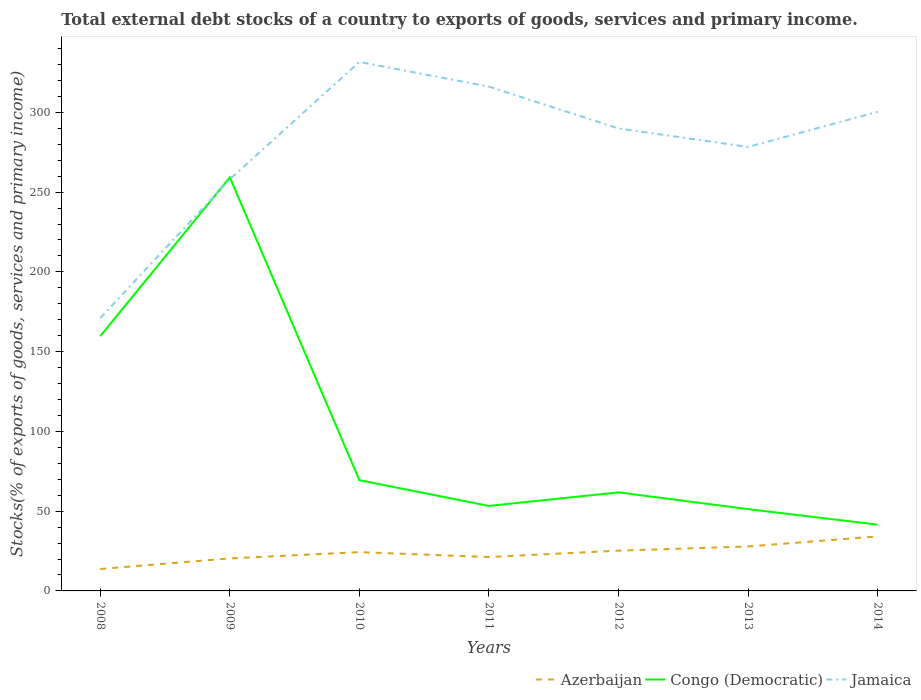Does the line corresponding to Jamaica intersect with the line corresponding to Azerbaijan?
Make the answer very short. No. Across all years, what is the maximum total debt stocks in Azerbaijan?
Provide a short and direct response. 13.75. In which year was the total debt stocks in Congo (Democratic) maximum?
Your answer should be compact. 2014. What is the total total debt stocks in Jamaica in the graph?
Your response must be concise. -10.41. What is the difference between the highest and the second highest total debt stocks in Jamaica?
Provide a succinct answer. 160.57. Is the total debt stocks in Jamaica strictly greater than the total debt stocks in Azerbaijan over the years?
Your answer should be compact. No. How many lines are there?
Make the answer very short. 3. How many years are there in the graph?
Offer a terse response. 7. Does the graph contain any zero values?
Your response must be concise. No. Where does the legend appear in the graph?
Offer a very short reply. Bottom right. What is the title of the graph?
Make the answer very short. Total external debt stocks of a country to exports of goods, services and primary income. Does "Germany" appear as one of the legend labels in the graph?
Ensure brevity in your answer.  No. What is the label or title of the Y-axis?
Offer a terse response. Stocks(% of exports of goods, services and primary income). What is the Stocks(% of exports of goods, services and primary income) in Azerbaijan in 2008?
Make the answer very short. 13.75. What is the Stocks(% of exports of goods, services and primary income) in Congo (Democratic) in 2008?
Your response must be concise. 159.7. What is the Stocks(% of exports of goods, services and primary income) of Jamaica in 2008?
Your answer should be very brief. 171.03. What is the Stocks(% of exports of goods, services and primary income) in Azerbaijan in 2009?
Give a very brief answer. 20.4. What is the Stocks(% of exports of goods, services and primary income) in Congo (Democratic) in 2009?
Your answer should be very brief. 259.23. What is the Stocks(% of exports of goods, services and primary income) of Jamaica in 2009?
Your answer should be compact. 258.03. What is the Stocks(% of exports of goods, services and primary income) in Azerbaijan in 2010?
Offer a very short reply. 24.31. What is the Stocks(% of exports of goods, services and primary income) of Congo (Democratic) in 2010?
Your response must be concise. 69.42. What is the Stocks(% of exports of goods, services and primary income) of Jamaica in 2010?
Keep it short and to the point. 331.59. What is the Stocks(% of exports of goods, services and primary income) of Azerbaijan in 2011?
Provide a short and direct response. 21.24. What is the Stocks(% of exports of goods, services and primary income) in Congo (Democratic) in 2011?
Ensure brevity in your answer.  53.28. What is the Stocks(% of exports of goods, services and primary income) of Jamaica in 2011?
Provide a succinct answer. 316.11. What is the Stocks(% of exports of goods, services and primary income) in Azerbaijan in 2012?
Offer a very short reply. 25.24. What is the Stocks(% of exports of goods, services and primary income) of Congo (Democratic) in 2012?
Make the answer very short. 61.78. What is the Stocks(% of exports of goods, services and primary income) in Jamaica in 2012?
Offer a terse response. 289.91. What is the Stocks(% of exports of goods, services and primary income) of Azerbaijan in 2013?
Provide a short and direct response. 27.87. What is the Stocks(% of exports of goods, services and primary income) in Congo (Democratic) in 2013?
Make the answer very short. 51.27. What is the Stocks(% of exports of goods, services and primary income) of Jamaica in 2013?
Your answer should be very brief. 278.31. What is the Stocks(% of exports of goods, services and primary income) in Azerbaijan in 2014?
Provide a succinct answer. 34.16. What is the Stocks(% of exports of goods, services and primary income) in Congo (Democratic) in 2014?
Keep it short and to the point. 41.55. What is the Stocks(% of exports of goods, services and primary income) of Jamaica in 2014?
Your answer should be compact. 300.32. Across all years, what is the maximum Stocks(% of exports of goods, services and primary income) of Azerbaijan?
Offer a terse response. 34.16. Across all years, what is the maximum Stocks(% of exports of goods, services and primary income) of Congo (Democratic)?
Give a very brief answer. 259.23. Across all years, what is the maximum Stocks(% of exports of goods, services and primary income) in Jamaica?
Give a very brief answer. 331.59. Across all years, what is the minimum Stocks(% of exports of goods, services and primary income) of Azerbaijan?
Offer a very short reply. 13.75. Across all years, what is the minimum Stocks(% of exports of goods, services and primary income) in Congo (Democratic)?
Your answer should be very brief. 41.55. Across all years, what is the minimum Stocks(% of exports of goods, services and primary income) of Jamaica?
Provide a short and direct response. 171.03. What is the total Stocks(% of exports of goods, services and primary income) in Azerbaijan in the graph?
Ensure brevity in your answer.  166.97. What is the total Stocks(% of exports of goods, services and primary income) of Congo (Democratic) in the graph?
Your answer should be compact. 696.24. What is the total Stocks(% of exports of goods, services and primary income) in Jamaica in the graph?
Offer a terse response. 1945.3. What is the difference between the Stocks(% of exports of goods, services and primary income) in Azerbaijan in 2008 and that in 2009?
Offer a terse response. -6.65. What is the difference between the Stocks(% of exports of goods, services and primary income) in Congo (Democratic) in 2008 and that in 2009?
Your answer should be very brief. -99.53. What is the difference between the Stocks(% of exports of goods, services and primary income) of Jamaica in 2008 and that in 2009?
Offer a very short reply. -87. What is the difference between the Stocks(% of exports of goods, services and primary income) in Azerbaijan in 2008 and that in 2010?
Keep it short and to the point. -10.57. What is the difference between the Stocks(% of exports of goods, services and primary income) of Congo (Democratic) in 2008 and that in 2010?
Your response must be concise. 90.29. What is the difference between the Stocks(% of exports of goods, services and primary income) in Jamaica in 2008 and that in 2010?
Give a very brief answer. -160.57. What is the difference between the Stocks(% of exports of goods, services and primary income) in Azerbaijan in 2008 and that in 2011?
Provide a short and direct response. -7.5. What is the difference between the Stocks(% of exports of goods, services and primary income) of Congo (Democratic) in 2008 and that in 2011?
Your answer should be compact. 106.42. What is the difference between the Stocks(% of exports of goods, services and primary income) of Jamaica in 2008 and that in 2011?
Make the answer very short. -145.09. What is the difference between the Stocks(% of exports of goods, services and primary income) in Azerbaijan in 2008 and that in 2012?
Provide a short and direct response. -11.5. What is the difference between the Stocks(% of exports of goods, services and primary income) in Congo (Democratic) in 2008 and that in 2012?
Your answer should be compact. 97.92. What is the difference between the Stocks(% of exports of goods, services and primary income) in Jamaica in 2008 and that in 2012?
Give a very brief answer. -118.88. What is the difference between the Stocks(% of exports of goods, services and primary income) in Azerbaijan in 2008 and that in 2013?
Make the answer very short. -14.12. What is the difference between the Stocks(% of exports of goods, services and primary income) in Congo (Democratic) in 2008 and that in 2013?
Your answer should be compact. 108.43. What is the difference between the Stocks(% of exports of goods, services and primary income) of Jamaica in 2008 and that in 2013?
Provide a succinct answer. -107.29. What is the difference between the Stocks(% of exports of goods, services and primary income) in Azerbaijan in 2008 and that in 2014?
Offer a very short reply. -20.41. What is the difference between the Stocks(% of exports of goods, services and primary income) of Congo (Democratic) in 2008 and that in 2014?
Your answer should be very brief. 118.15. What is the difference between the Stocks(% of exports of goods, services and primary income) in Jamaica in 2008 and that in 2014?
Offer a terse response. -129.3. What is the difference between the Stocks(% of exports of goods, services and primary income) in Azerbaijan in 2009 and that in 2010?
Your answer should be very brief. -3.92. What is the difference between the Stocks(% of exports of goods, services and primary income) in Congo (Democratic) in 2009 and that in 2010?
Provide a succinct answer. 189.82. What is the difference between the Stocks(% of exports of goods, services and primary income) of Jamaica in 2009 and that in 2010?
Your answer should be compact. -73.57. What is the difference between the Stocks(% of exports of goods, services and primary income) in Azerbaijan in 2009 and that in 2011?
Provide a short and direct response. -0.85. What is the difference between the Stocks(% of exports of goods, services and primary income) in Congo (Democratic) in 2009 and that in 2011?
Give a very brief answer. 205.95. What is the difference between the Stocks(% of exports of goods, services and primary income) of Jamaica in 2009 and that in 2011?
Keep it short and to the point. -58.09. What is the difference between the Stocks(% of exports of goods, services and primary income) of Azerbaijan in 2009 and that in 2012?
Provide a short and direct response. -4.85. What is the difference between the Stocks(% of exports of goods, services and primary income) in Congo (Democratic) in 2009 and that in 2012?
Provide a succinct answer. 197.45. What is the difference between the Stocks(% of exports of goods, services and primary income) of Jamaica in 2009 and that in 2012?
Provide a short and direct response. -31.88. What is the difference between the Stocks(% of exports of goods, services and primary income) of Azerbaijan in 2009 and that in 2013?
Ensure brevity in your answer.  -7.47. What is the difference between the Stocks(% of exports of goods, services and primary income) in Congo (Democratic) in 2009 and that in 2013?
Ensure brevity in your answer.  207.96. What is the difference between the Stocks(% of exports of goods, services and primary income) of Jamaica in 2009 and that in 2013?
Your answer should be very brief. -20.29. What is the difference between the Stocks(% of exports of goods, services and primary income) in Azerbaijan in 2009 and that in 2014?
Provide a succinct answer. -13.76. What is the difference between the Stocks(% of exports of goods, services and primary income) of Congo (Democratic) in 2009 and that in 2014?
Make the answer very short. 217.69. What is the difference between the Stocks(% of exports of goods, services and primary income) in Jamaica in 2009 and that in 2014?
Provide a short and direct response. -42.3. What is the difference between the Stocks(% of exports of goods, services and primary income) in Azerbaijan in 2010 and that in 2011?
Provide a short and direct response. 3.07. What is the difference between the Stocks(% of exports of goods, services and primary income) in Congo (Democratic) in 2010 and that in 2011?
Give a very brief answer. 16.13. What is the difference between the Stocks(% of exports of goods, services and primary income) in Jamaica in 2010 and that in 2011?
Make the answer very short. 15.48. What is the difference between the Stocks(% of exports of goods, services and primary income) in Azerbaijan in 2010 and that in 2012?
Your answer should be very brief. -0.93. What is the difference between the Stocks(% of exports of goods, services and primary income) of Congo (Democratic) in 2010 and that in 2012?
Offer a very short reply. 7.63. What is the difference between the Stocks(% of exports of goods, services and primary income) in Jamaica in 2010 and that in 2012?
Your answer should be very brief. 41.69. What is the difference between the Stocks(% of exports of goods, services and primary income) in Azerbaijan in 2010 and that in 2013?
Your answer should be very brief. -3.55. What is the difference between the Stocks(% of exports of goods, services and primary income) in Congo (Democratic) in 2010 and that in 2013?
Make the answer very short. 18.15. What is the difference between the Stocks(% of exports of goods, services and primary income) in Jamaica in 2010 and that in 2013?
Keep it short and to the point. 53.28. What is the difference between the Stocks(% of exports of goods, services and primary income) of Azerbaijan in 2010 and that in 2014?
Give a very brief answer. -9.85. What is the difference between the Stocks(% of exports of goods, services and primary income) of Congo (Democratic) in 2010 and that in 2014?
Your response must be concise. 27.87. What is the difference between the Stocks(% of exports of goods, services and primary income) of Jamaica in 2010 and that in 2014?
Ensure brevity in your answer.  31.27. What is the difference between the Stocks(% of exports of goods, services and primary income) of Azerbaijan in 2011 and that in 2012?
Give a very brief answer. -4. What is the difference between the Stocks(% of exports of goods, services and primary income) of Congo (Democratic) in 2011 and that in 2012?
Your answer should be compact. -8.5. What is the difference between the Stocks(% of exports of goods, services and primary income) in Jamaica in 2011 and that in 2012?
Offer a terse response. 26.21. What is the difference between the Stocks(% of exports of goods, services and primary income) in Azerbaijan in 2011 and that in 2013?
Ensure brevity in your answer.  -6.62. What is the difference between the Stocks(% of exports of goods, services and primary income) in Congo (Democratic) in 2011 and that in 2013?
Give a very brief answer. 2.01. What is the difference between the Stocks(% of exports of goods, services and primary income) of Jamaica in 2011 and that in 2013?
Keep it short and to the point. 37.8. What is the difference between the Stocks(% of exports of goods, services and primary income) in Azerbaijan in 2011 and that in 2014?
Offer a very short reply. -12.92. What is the difference between the Stocks(% of exports of goods, services and primary income) of Congo (Democratic) in 2011 and that in 2014?
Offer a terse response. 11.74. What is the difference between the Stocks(% of exports of goods, services and primary income) in Jamaica in 2011 and that in 2014?
Make the answer very short. 15.79. What is the difference between the Stocks(% of exports of goods, services and primary income) in Azerbaijan in 2012 and that in 2013?
Offer a very short reply. -2.62. What is the difference between the Stocks(% of exports of goods, services and primary income) in Congo (Democratic) in 2012 and that in 2013?
Offer a very short reply. 10.51. What is the difference between the Stocks(% of exports of goods, services and primary income) of Jamaica in 2012 and that in 2013?
Your answer should be very brief. 11.6. What is the difference between the Stocks(% of exports of goods, services and primary income) of Azerbaijan in 2012 and that in 2014?
Provide a short and direct response. -8.92. What is the difference between the Stocks(% of exports of goods, services and primary income) of Congo (Democratic) in 2012 and that in 2014?
Give a very brief answer. 20.24. What is the difference between the Stocks(% of exports of goods, services and primary income) in Jamaica in 2012 and that in 2014?
Your answer should be very brief. -10.41. What is the difference between the Stocks(% of exports of goods, services and primary income) of Azerbaijan in 2013 and that in 2014?
Give a very brief answer. -6.29. What is the difference between the Stocks(% of exports of goods, services and primary income) of Congo (Democratic) in 2013 and that in 2014?
Make the answer very short. 9.72. What is the difference between the Stocks(% of exports of goods, services and primary income) in Jamaica in 2013 and that in 2014?
Your response must be concise. -22.01. What is the difference between the Stocks(% of exports of goods, services and primary income) of Azerbaijan in 2008 and the Stocks(% of exports of goods, services and primary income) of Congo (Democratic) in 2009?
Your answer should be compact. -245.49. What is the difference between the Stocks(% of exports of goods, services and primary income) of Azerbaijan in 2008 and the Stocks(% of exports of goods, services and primary income) of Jamaica in 2009?
Provide a short and direct response. -244.28. What is the difference between the Stocks(% of exports of goods, services and primary income) of Congo (Democratic) in 2008 and the Stocks(% of exports of goods, services and primary income) of Jamaica in 2009?
Provide a short and direct response. -98.32. What is the difference between the Stocks(% of exports of goods, services and primary income) in Azerbaijan in 2008 and the Stocks(% of exports of goods, services and primary income) in Congo (Democratic) in 2010?
Your response must be concise. -55.67. What is the difference between the Stocks(% of exports of goods, services and primary income) in Azerbaijan in 2008 and the Stocks(% of exports of goods, services and primary income) in Jamaica in 2010?
Your answer should be compact. -317.85. What is the difference between the Stocks(% of exports of goods, services and primary income) of Congo (Democratic) in 2008 and the Stocks(% of exports of goods, services and primary income) of Jamaica in 2010?
Your response must be concise. -171.89. What is the difference between the Stocks(% of exports of goods, services and primary income) in Azerbaijan in 2008 and the Stocks(% of exports of goods, services and primary income) in Congo (Democratic) in 2011?
Your answer should be compact. -39.54. What is the difference between the Stocks(% of exports of goods, services and primary income) in Azerbaijan in 2008 and the Stocks(% of exports of goods, services and primary income) in Jamaica in 2011?
Ensure brevity in your answer.  -302.37. What is the difference between the Stocks(% of exports of goods, services and primary income) in Congo (Democratic) in 2008 and the Stocks(% of exports of goods, services and primary income) in Jamaica in 2011?
Make the answer very short. -156.41. What is the difference between the Stocks(% of exports of goods, services and primary income) of Azerbaijan in 2008 and the Stocks(% of exports of goods, services and primary income) of Congo (Democratic) in 2012?
Provide a succinct answer. -48.04. What is the difference between the Stocks(% of exports of goods, services and primary income) in Azerbaijan in 2008 and the Stocks(% of exports of goods, services and primary income) in Jamaica in 2012?
Ensure brevity in your answer.  -276.16. What is the difference between the Stocks(% of exports of goods, services and primary income) in Congo (Democratic) in 2008 and the Stocks(% of exports of goods, services and primary income) in Jamaica in 2012?
Provide a short and direct response. -130.21. What is the difference between the Stocks(% of exports of goods, services and primary income) in Azerbaijan in 2008 and the Stocks(% of exports of goods, services and primary income) in Congo (Democratic) in 2013?
Offer a terse response. -37.52. What is the difference between the Stocks(% of exports of goods, services and primary income) of Azerbaijan in 2008 and the Stocks(% of exports of goods, services and primary income) of Jamaica in 2013?
Your response must be concise. -264.56. What is the difference between the Stocks(% of exports of goods, services and primary income) in Congo (Democratic) in 2008 and the Stocks(% of exports of goods, services and primary income) in Jamaica in 2013?
Provide a short and direct response. -118.61. What is the difference between the Stocks(% of exports of goods, services and primary income) of Azerbaijan in 2008 and the Stocks(% of exports of goods, services and primary income) of Congo (Democratic) in 2014?
Offer a very short reply. -27.8. What is the difference between the Stocks(% of exports of goods, services and primary income) of Azerbaijan in 2008 and the Stocks(% of exports of goods, services and primary income) of Jamaica in 2014?
Keep it short and to the point. -286.57. What is the difference between the Stocks(% of exports of goods, services and primary income) of Congo (Democratic) in 2008 and the Stocks(% of exports of goods, services and primary income) of Jamaica in 2014?
Ensure brevity in your answer.  -140.62. What is the difference between the Stocks(% of exports of goods, services and primary income) in Azerbaijan in 2009 and the Stocks(% of exports of goods, services and primary income) in Congo (Democratic) in 2010?
Your response must be concise. -49.02. What is the difference between the Stocks(% of exports of goods, services and primary income) of Azerbaijan in 2009 and the Stocks(% of exports of goods, services and primary income) of Jamaica in 2010?
Offer a terse response. -311.2. What is the difference between the Stocks(% of exports of goods, services and primary income) of Congo (Democratic) in 2009 and the Stocks(% of exports of goods, services and primary income) of Jamaica in 2010?
Keep it short and to the point. -72.36. What is the difference between the Stocks(% of exports of goods, services and primary income) in Azerbaijan in 2009 and the Stocks(% of exports of goods, services and primary income) in Congo (Democratic) in 2011?
Provide a succinct answer. -32.89. What is the difference between the Stocks(% of exports of goods, services and primary income) in Azerbaijan in 2009 and the Stocks(% of exports of goods, services and primary income) in Jamaica in 2011?
Provide a succinct answer. -295.72. What is the difference between the Stocks(% of exports of goods, services and primary income) of Congo (Democratic) in 2009 and the Stocks(% of exports of goods, services and primary income) of Jamaica in 2011?
Provide a short and direct response. -56.88. What is the difference between the Stocks(% of exports of goods, services and primary income) of Azerbaijan in 2009 and the Stocks(% of exports of goods, services and primary income) of Congo (Democratic) in 2012?
Provide a succinct answer. -41.39. What is the difference between the Stocks(% of exports of goods, services and primary income) of Azerbaijan in 2009 and the Stocks(% of exports of goods, services and primary income) of Jamaica in 2012?
Offer a very short reply. -269.51. What is the difference between the Stocks(% of exports of goods, services and primary income) in Congo (Democratic) in 2009 and the Stocks(% of exports of goods, services and primary income) in Jamaica in 2012?
Offer a terse response. -30.67. What is the difference between the Stocks(% of exports of goods, services and primary income) in Azerbaijan in 2009 and the Stocks(% of exports of goods, services and primary income) in Congo (Democratic) in 2013?
Make the answer very short. -30.87. What is the difference between the Stocks(% of exports of goods, services and primary income) of Azerbaijan in 2009 and the Stocks(% of exports of goods, services and primary income) of Jamaica in 2013?
Your answer should be very brief. -257.91. What is the difference between the Stocks(% of exports of goods, services and primary income) of Congo (Democratic) in 2009 and the Stocks(% of exports of goods, services and primary income) of Jamaica in 2013?
Give a very brief answer. -19.08. What is the difference between the Stocks(% of exports of goods, services and primary income) in Azerbaijan in 2009 and the Stocks(% of exports of goods, services and primary income) in Congo (Democratic) in 2014?
Offer a terse response. -21.15. What is the difference between the Stocks(% of exports of goods, services and primary income) of Azerbaijan in 2009 and the Stocks(% of exports of goods, services and primary income) of Jamaica in 2014?
Give a very brief answer. -279.92. What is the difference between the Stocks(% of exports of goods, services and primary income) of Congo (Democratic) in 2009 and the Stocks(% of exports of goods, services and primary income) of Jamaica in 2014?
Keep it short and to the point. -41.09. What is the difference between the Stocks(% of exports of goods, services and primary income) in Azerbaijan in 2010 and the Stocks(% of exports of goods, services and primary income) in Congo (Democratic) in 2011?
Your answer should be very brief. -28.97. What is the difference between the Stocks(% of exports of goods, services and primary income) of Azerbaijan in 2010 and the Stocks(% of exports of goods, services and primary income) of Jamaica in 2011?
Offer a terse response. -291.8. What is the difference between the Stocks(% of exports of goods, services and primary income) of Congo (Democratic) in 2010 and the Stocks(% of exports of goods, services and primary income) of Jamaica in 2011?
Ensure brevity in your answer.  -246.7. What is the difference between the Stocks(% of exports of goods, services and primary income) of Azerbaijan in 2010 and the Stocks(% of exports of goods, services and primary income) of Congo (Democratic) in 2012?
Offer a terse response. -37.47. What is the difference between the Stocks(% of exports of goods, services and primary income) of Azerbaijan in 2010 and the Stocks(% of exports of goods, services and primary income) of Jamaica in 2012?
Offer a terse response. -265.6. What is the difference between the Stocks(% of exports of goods, services and primary income) in Congo (Democratic) in 2010 and the Stocks(% of exports of goods, services and primary income) in Jamaica in 2012?
Your answer should be very brief. -220.49. What is the difference between the Stocks(% of exports of goods, services and primary income) of Azerbaijan in 2010 and the Stocks(% of exports of goods, services and primary income) of Congo (Democratic) in 2013?
Provide a short and direct response. -26.96. What is the difference between the Stocks(% of exports of goods, services and primary income) of Azerbaijan in 2010 and the Stocks(% of exports of goods, services and primary income) of Jamaica in 2013?
Offer a terse response. -254. What is the difference between the Stocks(% of exports of goods, services and primary income) of Congo (Democratic) in 2010 and the Stocks(% of exports of goods, services and primary income) of Jamaica in 2013?
Offer a terse response. -208.89. What is the difference between the Stocks(% of exports of goods, services and primary income) in Azerbaijan in 2010 and the Stocks(% of exports of goods, services and primary income) in Congo (Democratic) in 2014?
Your answer should be very brief. -17.23. What is the difference between the Stocks(% of exports of goods, services and primary income) of Azerbaijan in 2010 and the Stocks(% of exports of goods, services and primary income) of Jamaica in 2014?
Offer a very short reply. -276.01. What is the difference between the Stocks(% of exports of goods, services and primary income) in Congo (Democratic) in 2010 and the Stocks(% of exports of goods, services and primary income) in Jamaica in 2014?
Ensure brevity in your answer.  -230.9. What is the difference between the Stocks(% of exports of goods, services and primary income) in Azerbaijan in 2011 and the Stocks(% of exports of goods, services and primary income) in Congo (Democratic) in 2012?
Your response must be concise. -40.54. What is the difference between the Stocks(% of exports of goods, services and primary income) in Azerbaijan in 2011 and the Stocks(% of exports of goods, services and primary income) in Jamaica in 2012?
Provide a succinct answer. -268.67. What is the difference between the Stocks(% of exports of goods, services and primary income) in Congo (Democratic) in 2011 and the Stocks(% of exports of goods, services and primary income) in Jamaica in 2012?
Offer a very short reply. -236.62. What is the difference between the Stocks(% of exports of goods, services and primary income) of Azerbaijan in 2011 and the Stocks(% of exports of goods, services and primary income) of Congo (Democratic) in 2013?
Your answer should be compact. -30.03. What is the difference between the Stocks(% of exports of goods, services and primary income) in Azerbaijan in 2011 and the Stocks(% of exports of goods, services and primary income) in Jamaica in 2013?
Provide a succinct answer. -257.07. What is the difference between the Stocks(% of exports of goods, services and primary income) of Congo (Democratic) in 2011 and the Stocks(% of exports of goods, services and primary income) of Jamaica in 2013?
Provide a short and direct response. -225.03. What is the difference between the Stocks(% of exports of goods, services and primary income) of Azerbaijan in 2011 and the Stocks(% of exports of goods, services and primary income) of Congo (Democratic) in 2014?
Your answer should be compact. -20.3. What is the difference between the Stocks(% of exports of goods, services and primary income) in Azerbaijan in 2011 and the Stocks(% of exports of goods, services and primary income) in Jamaica in 2014?
Your answer should be very brief. -279.08. What is the difference between the Stocks(% of exports of goods, services and primary income) of Congo (Democratic) in 2011 and the Stocks(% of exports of goods, services and primary income) of Jamaica in 2014?
Your answer should be very brief. -247.04. What is the difference between the Stocks(% of exports of goods, services and primary income) in Azerbaijan in 2012 and the Stocks(% of exports of goods, services and primary income) in Congo (Democratic) in 2013?
Ensure brevity in your answer.  -26.03. What is the difference between the Stocks(% of exports of goods, services and primary income) in Azerbaijan in 2012 and the Stocks(% of exports of goods, services and primary income) in Jamaica in 2013?
Your answer should be compact. -253.07. What is the difference between the Stocks(% of exports of goods, services and primary income) of Congo (Democratic) in 2012 and the Stocks(% of exports of goods, services and primary income) of Jamaica in 2013?
Provide a succinct answer. -216.53. What is the difference between the Stocks(% of exports of goods, services and primary income) of Azerbaijan in 2012 and the Stocks(% of exports of goods, services and primary income) of Congo (Democratic) in 2014?
Offer a terse response. -16.3. What is the difference between the Stocks(% of exports of goods, services and primary income) in Azerbaijan in 2012 and the Stocks(% of exports of goods, services and primary income) in Jamaica in 2014?
Ensure brevity in your answer.  -275.08. What is the difference between the Stocks(% of exports of goods, services and primary income) in Congo (Democratic) in 2012 and the Stocks(% of exports of goods, services and primary income) in Jamaica in 2014?
Your answer should be compact. -238.54. What is the difference between the Stocks(% of exports of goods, services and primary income) of Azerbaijan in 2013 and the Stocks(% of exports of goods, services and primary income) of Congo (Democratic) in 2014?
Provide a succinct answer. -13.68. What is the difference between the Stocks(% of exports of goods, services and primary income) in Azerbaijan in 2013 and the Stocks(% of exports of goods, services and primary income) in Jamaica in 2014?
Ensure brevity in your answer.  -272.45. What is the difference between the Stocks(% of exports of goods, services and primary income) of Congo (Democratic) in 2013 and the Stocks(% of exports of goods, services and primary income) of Jamaica in 2014?
Keep it short and to the point. -249.05. What is the average Stocks(% of exports of goods, services and primary income) of Azerbaijan per year?
Your answer should be compact. 23.85. What is the average Stocks(% of exports of goods, services and primary income) in Congo (Democratic) per year?
Keep it short and to the point. 99.46. What is the average Stocks(% of exports of goods, services and primary income) of Jamaica per year?
Make the answer very short. 277.9. In the year 2008, what is the difference between the Stocks(% of exports of goods, services and primary income) in Azerbaijan and Stocks(% of exports of goods, services and primary income) in Congo (Democratic)?
Make the answer very short. -145.95. In the year 2008, what is the difference between the Stocks(% of exports of goods, services and primary income) of Azerbaijan and Stocks(% of exports of goods, services and primary income) of Jamaica?
Keep it short and to the point. -157.28. In the year 2008, what is the difference between the Stocks(% of exports of goods, services and primary income) of Congo (Democratic) and Stocks(% of exports of goods, services and primary income) of Jamaica?
Your answer should be compact. -11.32. In the year 2009, what is the difference between the Stocks(% of exports of goods, services and primary income) of Azerbaijan and Stocks(% of exports of goods, services and primary income) of Congo (Democratic)?
Offer a very short reply. -238.84. In the year 2009, what is the difference between the Stocks(% of exports of goods, services and primary income) in Azerbaijan and Stocks(% of exports of goods, services and primary income) in Jamaica?
Provide a short and direct response. -237.63. In the year 2009, what is the difference between the Stocks(% of exports of goods, services and primary income) in Congo (Democratic) and Stocks(% of exports of goods, services and primary income) in Jamaica?
Your answer should be very brief. 1.21. In the year 2010, what is the difference between the Stocks(% of exports of goods, services and primary income) of Azerbaijan and Stocks(% of exports of goods, services and primary income) of Congo (Democratic)?
Offer a terse response. -45.1. In the year 2010, what is the difference between the Stocks(% of exports of goods, services and primary income) in Azerbaijan and Stocks(% of exports of goods, services and primary income) in Jamaica?
Offer a terse response. -307.28. In the year 2010, what is the difference between the Stocks(% of exports of goods, services and primary income) in Congo (Democratic) and Stocks(% of exports of goods, services and primary income) in Jamaica?
Offer a very short reply. -262.18. In the year 2011, what is the difference between the Stocks(% of exports of goods, services and primary income) of Azerbaijan and Stocks(% of exports of goods, services and primary income) of Congo (Democratic)?
Your answer should be very brief. -32.04. In the year 2011, what is the difference between the Stocks(% of exports of goods, services and primary income) in Azerbaijan and Stocks(% of exports of goods, services and primary income) in Jamaica?
Your response must be concise. -294.87. In the year 2011, what is the difference between the Stocks(% of exports of goods, services and primary income) of Congo (Democratic) and Stocks(% of exports of goods, services and primary income) of Jamaica?
Offer a terse response. -262.83. In the year 2012, what is the difference between the Stocks(% of exports of goods, services and primary income) in Azerbaijan and Stocks(% of exports of goods, services and primary income) in Congo (Democratic)?
Your answer should be very brief. -36.54. In the year 2012, what is the difference between the Stocks(% of exports of goods, services and primary income) in Azerbaijan and Stocks(% of exports of goods, services and primary income) in Jamaica?
Keep it short and to the point. -264.67. In the year 2012, what is the difference between the Stocks(% of exports of goods, services and primary income) in Congo (Democratic) and Stocks(% of exports of goods, services and primary income) in Jamaica?
Provide a succinct answer. -228.12. In the year 2013, what is the difference between the Stocks(% of exports of goods, services and primary income) of Azerbaijan and Stocks(% of exports of goods, services and primary income) of Congo (Democratic)?
Your answer should be compact. -23.4. In the year 2013, what is the difference between the Stocks(% of exports of goods, services and primary income) of Azerbaijan and Stocks(% of exports of goods, services and primary income) of Jamaica?
Your response must be concise. -250.44. In the year 2013, what is the difference between the Stocks(% of exports of goods, services and primary income) in Congo (Democratic) and Stocks(% of exports of goods, services and primary income) in Jamaica?
Offer a very short reply. -227.04. In the year 2014, what is the difference between the Stocks(% of exports of goods, services and primary income) of Azerbaijan and Stocks(% of exports of goods, services and primary income) of Congo (Democratic)?
Offer a very short reply. -7.39. In the year 2014, what is the difference between the Stocks(% of exports of goods, services and primary income) in Azerbaijan and Stocks(% of exports of goods, services and primary income) in Jamaica?
Keep it short and to the point. -266.16. In the year 2014, what is the difference between the Stocks(% of exports of goods, services and primary income) of Congo (Democratic) and Stocks(% of exports of goods, services and primary income) of Jamaica?
Offer a terse response. -258.77. What is the ratio of the Stocks(% of exports of goods, services and primary income) of Azerbaijan in 2008 to that in 2009?
Give a very brief answer. 0.67. What is the ratio of the Stocks(% of exports of goods, services and primary income) of Congo (Democratic) in 2008 to that in 2009?
Your answer should be compact. 0.62. What is the ratio of the Stocks(% of exports of goods, services and primary income) in Jamaica in 2008 to that in 2009?
Provide a short and direct response. 0.66. What is the ratio of the Stocks(% of exports of goods, services and primary income) in Azerbaijan in 2008 to that in 2010?
Your answer should be compact. 0.57. What is the ratio of the Stocks(% of exports of goods, services and primary income) in Congo (Democratic) in 2008 to that in 2010?
Offer a terse response. 2.3. What is the ratio of the Stocks(% of exports of goods, services and primary income) in Jamaica in 2008 to that in 2010?
Keep it short and to the point. 0.52. What is the ratio of the Stocks(% of exports of goods, services and primary income) of Azerbaijan in 2008 to that in 2011?
Your answer should be very brief. 0.65. What is the ratio of the Stocks(% of exports of goods, services and primary income) in Congo (Democratic) in 2008 to that in 2011?
Your answer should be very brief. 3. What is the ratio of the Stocks(% of exports of goods, services and primary income) of Jamaica in 2008 to that in 2011?
Your response must be concise. 0.54. What is the ratio of the Stocks(% of exports of goods, services and primary income) of Azerbaijan in 2008 to that in 2012?
Give a very brief answer. 0.54. What is the ratio of the Stocks(% of exports of goods, services and primary income) of Congo (Democratic) in 2008 to that in 2012?
Keep it short and to the point. 2.58. What is the ratio of the Stocks(% of exports of goods, services and primary income) of Jamaica in 2008 to that in 2012?
Your answer should be compact. 0.59. What is the ratio of the Stocks(% of exports of goods, services and primary income) of Azerbaijan in 2008 to that in 2013?
Offer a very short reply. 0.49. What is the ratio of the Stocks(% of exports of goods, services and primary income) in Congo (Democratic) in 2008 to that in 2013?
Make the answer very short. 3.11. What is the ratio of the Stocks(% of exports of goods, services and primary income) of Jamaica in 2008 to that in 2013?
Ensure brevity in your answer.  0.61. What is the ratio of the Stocks(% of exports of goods, services and primary income) in Azerbaijan in 2008 to that in 2014?
Provide a short and direct response. 0.4. What is the ratio of the Stocks(% of exports of goods, services and primary income) in Congo (Democratic) in 2008 to that in 2014?
Make the answer very short. 3.84. What is the ratio of the Stocks(% of exports of goods, services and primary income) in Jamaica in 2008 to that in 2014?
Give a very brief answer. 0.57. What is the ratio of the Stocks(% of exports of goods, services and primary income) in Azerbaijan in 2009 to that in 2010?
Make the answer very short. 0.84. What is the ratio of the Stocks(% of exports of goods, services and primary income) of Congo (Democratic) in 2009 to that in 2010?
Your answer should be compact. 3.73. What is the ratio of the Stocks(% of exports of goods, services and primary income) of Jamaica in 2009 to that in 2010?
Your answer should be compact. 0.78. What is the ratio of the Stocks(% of exports of goods, services and primary income) in Azerbaijan in 2009 to that in 2011?
Ensure brevity in your answer.  0.96. What is the ratio of the Stocks(% of exports of goods, services and primary income) of Congo (Democratic) in 2009 to that in 2011?
Offer a very short reply. 4.87. What is the ratio of the Stocks(% of exports of goods, services and primary income) in Jamaica in 2009 to that in 2011?
Offer a very short reply. 0.82. What is the ratio of the Stocks(% of exports of goods, services and primary income) in Azerbaijan in 2009 to that in 2012?
Provide a succinct answer. 0.81. What is the ratio of the Stocks(% of exports of goods, services and primary income) of Congo (Democratic) in 2009 to that in 2012?
Give a very brief answer. 4.2. What is the ratio of the Stocks(% of exports of goods, services and primary income) of Jamaica in 2009 to that in 2012?
Make the answer very short. 0.89. What is the ratio of the Stocks(% of exports of goods, services and primary income) of Azerbaijan in 2009 to that in 2013?
Make the answer very short. 0.73. What is the ratio of the Stocks(% of exports of goods, services and primary income) of Congo (Democratic) in 2009 to that in 2013?
Give a very brief answer. 5.06. What is the ratio of the Stocks(% of exports of goods, services and primary income) in Jamaica in 2009 to that in 2013?
Offer a terse response. 0.93. What is the ratio of the Stocks(% of exports of goods, services and primary income) in Azerbaijan in 2009 to that in 2014?
Provide a succinct answer. 0.6. What is the ratio of the Stocks(% of exports of goods, services and primary income) of Congo (Democratic) in 2009 to that in 2014?
Ensure brevity in your answer.  6.24. What is the ratio of the Stocks(% of exports of goods, services and primary income) of Jamaica in 2009 to that in 2014?
Provide a short and direct response. 0.86. What is the ratio of the Stocks(% of exports of goods, services and primary income) in Azerbaijan in 2010 to that in 2011?
Offer a very short reply. 1.14. What is the ratio of the Stocks(% of exports of goods, services and primary income) in Congo (Democratic) in 2010 to that in 2011?
Ensure brevity in your answer.  1.3. What is the ratio of the Stocks(% of exports of goods, services and primary income) in Jamaica in 2010 to that in 2011?
Keep it short and to the point. 1.05. What is the ratio of the Stocks(% of exports of goods, services and primary income) in Azerbaijan in 2010 to that in 2012?
Offer a terse response. 0.96. What is the ratio of the Stocks(% of exports of goods, services and primary income) in Congo (Democratic) in 2010 to that in 2012?
Give a very brief answer. 1.12. What is the ratio of the Stocks(% of exports of goods, services and primary income) in Jamaica in 2010 to that in 2012?
Provide a succinct answer. 1.14. What is the ratio of the Stocks(% of exports of goods, services and primary income) of Azerbaijan in 2010 to that in 2013?
Make the answer very short. 0.87. What is the ratio of the Stocks(% of exports of goods, services and primary income) of Congo (Democratic) in 2010 to that in 2013?
Offer a terse response. 1.35. What is the ratio of the Stocks(% of exports of goods, services and primary income) in Jamaica in 2010 to that in 2013?
Give a very brief answer. 1.19. What is the ratio of the Stocks(% of exports of goods, services and primary income) in Azerbaijan in 2010 to that in 2014?
Keep it short and to the point. 0.71. What is the ratio of the Stocks(% of exports of goods, services and primary income) in Congo (Democratic) in 2010 to that in 2014?
Make the answer very short. 1.67. What is the ratio of the Stocks(% of exports of goods, services and primary income) in Jamaica in 2010 to that in 2014?
Your answer should be compact. 1.1. What is the ratio of the Stocks(% of exports of goods, services and primary income) of Azerbaijan in 2011 to that in 2012?
Keep it short and to the point. 0.84. What is the ratio of the Stocks(% of exports of goods, services and primary income) of Congo (Democratic) in 2011 to that in 2012?
Offer a very short reply. 0.86. What is the ratio of the Stocks(% of exports of goods, services and primary income) in Jamaica in 2011 to that in 2012?
Keep it short and to the point. 1.09. What is the ratio of the Stocks(% of exports of goods, services and primary income) of Azerbaijan in 2011 to that in 2013?
Your response must be concise. 0.76. What is the ratio of the Stocks(% of exports of goods, services and primary income) in Congo (Democratic) in 2011 to that in 2013?
Offer a very short reply. 1.04. What is the ratio of the Stocks(% of exports of goods, services and primary income) of Jamaica in 2011 to that in 2013?
Provide a succinct answer. 1.14. What is the ratio of the Stocks(% of exports of goods, services and primary income) of Azerbaijan in 2011 to that in 2014?
Your answer should be very brief. 0.62. What is the ratio of the Stocks(% of exports of goods, services and primary income) in Congo (Democratic) in 2011 to that in 2014?
Make the answer very short. 1.28. What is the ratio of the Stocks(% of exports of goods, services and primary income) of Jamaica in 2011 to that in 2014?
Make the answer very short. 1.05. What is the ratio of the Stocks(% of exports of goods, services and primary income) in Azerbaijan in 2012 to that in 2013?
Your response must be concise. 0.91. What is the ratio of the Stocks(% of exports of goods, services and primary income) in Congo (Democratic) in 2012 to that in 2013?
Keep it short and to the point. 1.21. What is the ratio of the Stocks(% of exports of goods, services and primary income) of Jamaica in 2012 to that in 2013?
Make the answer very short. 1.04. What is the ratio of the Stocks(% of exports of goods, services and primary income) in Azerbaijan in 2012 to that in 2014?
Ensure brevity in your answer.  0.74. What is the ratio of the Stocks(% of exports of goods, services and primary income) in Congo (Democratic) in 2012 to that in 2014?
Provide a succinct answer. 1.49. What is the ratio of the Stocks(% of exports of goods, services and primary income) in Jamaica in 2012 to that in 2014?
Your answer should be compact. 0.97. What is the ratio of the Stocks(% of exports of goods, services and primary income) of Azerbaijan in 2013 to that in 2014?
Offer a very short reply. 0.82. What is the ratio of the Stocks(% of exports of goods, services and primary income) of Congo (Democratic) in 2013 to that in 2014?
Provide a succinct answer. 1.23. What is the ratio of the Stocks(% of exports of goods, services and primary income) of Jamaica in 2013 to that in 2014?
Provide a short and direct response. 0.93. What is the difference between the highest and the second highest Stocks(% of exports of goods, services and primary income) in Azerbaijan?
Provide a short and direct response. 6.29. What is the difference between the highest and the second highest Stocks(% of exports of goods, services and primary income) in Congo (Democratic)?
Offer a terse response. 99.53. What is the difference between the highest and the second highest Stocks(% of exports of goods, services and primary income) of Jamaica?
Ensure brevity in your answer.  15.48. What is the difference between the highest and the lowest Stocks(% of exports of goods, services and primary income) in Azerbaijan?
Offer a very short reply. 20.41. What is the difference between the highest and the lowest Stocks(% of exports of goods, services and primary income) of Congo (Democratic)?
Provide a succinct answer. 217.69. What is the difference between the highest and the lowest Stocks(% of exports of goods, services and primary income) of Jamaica?
Provide a short and direct response. 160.57. 